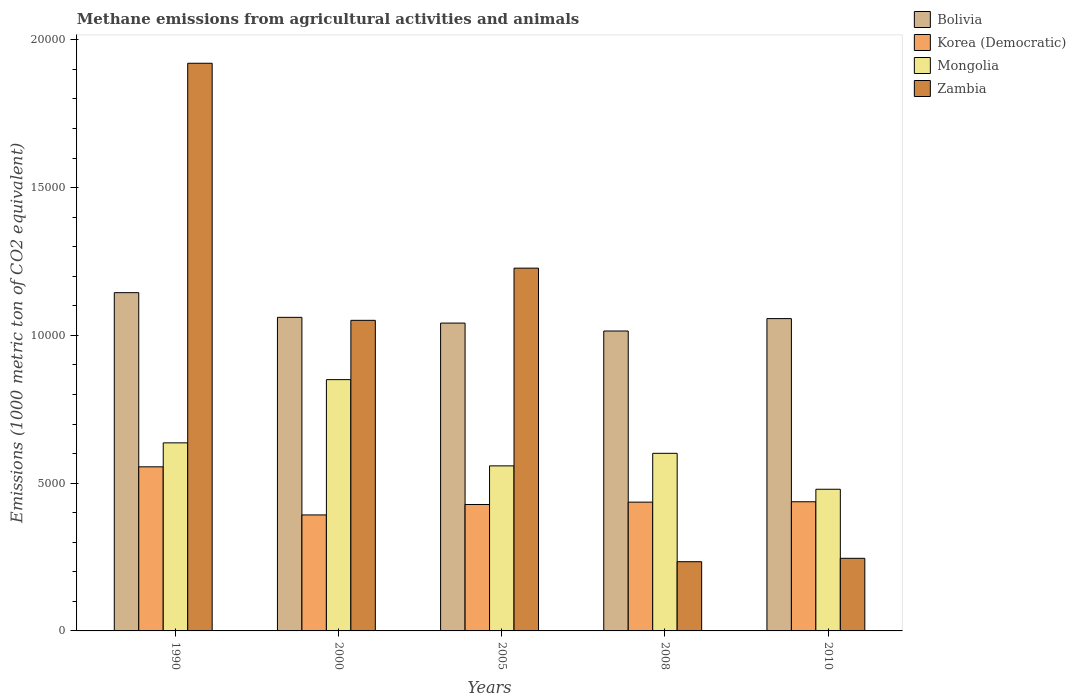Are the number of bars per tick equal to the number of legend labels?
Your answer should be compact. Yes. How many bars are there on the 5th tick from the right?
Make the answer very short. 4. In how many cases, is the number of bars for a given year not equal to the number of legend labels?
Offer a very short reply. 0. What is the amount of methane emitted in Bolivia in 2005?
Give a very brief answer. 1.04e+04. Across all years, what is the maximum amount of methane emitted in Mongolia?
Offer a terse response. 8502.3. Across all years, what is the minimum amount of methane emitted in Zambia?
Provide a short and direct response. 2342.5. What is the total amount of methane emitted in Mongolia in the graph?
Your answer should be very brief. 3.13e+04. What is the difference between the amount of methane emitted in Bolivia in 2000 and that in 2008?
Offer a terse response. 462.2. What is the difference between the amount of methane emitted in Bolivia in 2008 and the amount of methane emitted in Korea (Democratic) in 1990?
Ensure brevity in your answer.  4595.1. What is the average amount of methane emitted in Korea (Democratic) per year?
Give a very brief answer. 4496.54. In the year 2008, what is the difference between the amount of methane emitted in Zambia and amount of methane emitted in Korea (Democratic)?
Provide a succinct answer. -2015.3. What is the ratio of the amount of methane emitted in Korea (Democratic) in 2000 to that in 2010?
Offer a terse response. 0.9. Is the amount of methane emitted in Bolivia in 2005 less than that in 2010?
Give a very brief answer. Yes. What is the difference between the highest and the second highest amount of methane emitted in Mongolia?
Your answer should be very brief. 2138.8. What is the difference between the highest and the lowest amount of methane emitted in Zambia?
Give a very brief answer. 1.69e+04. Is the sum of the amount of methane emitted in Mongolia in 1990 and 2005 greater than the maximum amount of methane emitted in Korea (Democratic) across all years?
Offer a very short reply. Yes. What does the 3rd bar from the left in 2000 represents?
Offer a very short reply. Mongolia. What does the 2nd bar from the right in 2000 represents?
Provide a short and direct response. Mongolia. Is it the case that in every year, the sum of the amount of methane emitted in Korea (Democratic) and amount of methane emitted in Mongolia is greater than the amount of methane emitted in Bolivia?
Provide a succinct answer. No. Are all the bars in the graph horizontal?
Offer a very short reply. No. How many years are there in the graph?
Offer a terse response. 5. What is the difference between two consecutive major ticks on the Y-axis?
Offer a very short reply. 5000. Does the graph contain any zero values?
Your response must be concise. No. Where does the legend appear in the graph?
Your answer should be compact. Top right. How are the legend labels stacked?
Your answer should be very brief. Vertical. What is the title of the graph?
Keep it short and to the point. Methane emissions from agricultural activities and animals. Does "Zimbabwe" appear as one of the legend labels in the graph?
Make the answer very short. No. What is the label or title of the X-axis?
Offer a very short reply. Years. What is the label or title of the Y-axis?
Offer a terse response. Emissions (1000 metric ton of CO2 equivalent). What is the Emissions (1000 metric ton of CO2 equivalent) of Bolivia in 1990?
Your answer should be very brief. 1.14e+04. What is the Emissions (1000 metric ton of CO2 equivalent) in Korea (Democratic) in 1990?
Provide a succinct answer. 5552.4. What is the Emissions (1000 metric ton of CO2 equivalent) in Mongolia in 1990?
Make the answer very short. 6363.5. What is the Emissions (1000 metric ton of CO2 equivalent) in Zambia in 1990?
Offer a very short reply. 1.92e+04. What is the Emissions (1000 metric ton of CO2 equivalent) in Bolivia in 2000?
Keep it short and to the point. 1.06e+04. What is the Emissions (1000 metric ton of CO2 equivalent) in Korea (Democratic) in 2000?
Your response must be concise. 3924.5. What is the Emissions (1000 metric ton of CO2 equivalent) of Mongolia in 2000?
Your response must be concise. 8502.3. What is the Emissions (1000 metric ton of CO2 equivalent) of Zambia in 2000?
Your answer should be very brief. 1.05e+04. What is the Emissions (1000 metric ton of CO2 equivalent) of Bolivia in 2005?
Ensure brevity in your answer.  1.04e+04. What is the Emissions (1000 metric ton of CO2 equivalent) of Korea (Democratic) in 2005?
Your answer should be compact. 4277.9. What is the Emissions (1000 metric ton of CO2 equivalent) of Mongolia in 2005?
Keep it short and to the point. 5584.9. What is the Emissions (1000 metric ton of CO2 equivalent) in Zambia in 2005?
Your answer should be compact. 1.23e+04. What is the Emissions (1000 metric ton of CO2 equivalent) in Bolivia in 2008?
Make the answer very short. 1.01e+04. What is the Emissions (1000 metric ton of CO2 equivalent) in Korea (Democratic) in 2008?
Offer a very short reply. 4357.8. What is the Emissions (1000 metric ton of CO2 equivalent) of Mongolia in 2008?
Offer a very short reply. 6009.3. What is the Emissions (1000 metric ton of CO2 equivalent) of Zambia in 2008?
Offer a very short reply. 2342.5. What is the Emissions (1000 metric ton of CO2 equivalent) of Bolivia in 2010?
Your answer should be very brief. 1.06e+04. What is the Emissions (1000 metric ton of CO2 equivalent) in Korea (Democratic) in 2010?
Ensure brevity in your answer.  4370.1. What is the Emissions (1000 metric ton of CO2 equivalent) in Mongolia in 2010?
Offer a very short reply. 4793.5. What is the Emissions (1000 metric ton of CO2 equivalent) in Zambia in 2010?
Keep it short and to the point. 2457.2. Across all years, what is the maximum Emissions (1000 metric ton of CO2 equivalent) in Bolivia?
Your answer should be very brief. 1.14e+04. Across all years, what is the maximum Emissions (1000 metric ton of CO2 equivalent) in Korea (Democratic)?
Provide a short and direct response. 5552.4. Across all years, what is the maximum Emissions (1000 metric ton of CO2 equivalent) of Mongolia?
Your answer should be compact. 8502.3. Across all years, what is the maximum Emissions (1000 metric ton of CO2 equivalent) of Zambia?
Give a very brief answer. 1.92e+04. Across all years, what is the minimum Emissions (1000 metric ton of CO2 equivalent) of Bolivia?
Give a very brief answer. 1.01e+04. Across all years, what is the minimum Emissions (1000 metric ton of CO2 equivalent) in Korea (Democratic)?
Provide a succinct answer. 3924.5. Across all years, what is the minimum Emissions (1000 metric ton of CO2 equivalent) of Mongolia?
Your response must be concise. 4793.5. Across all years, what is the minimum Emissions (1000 metric ton of CO2 equivalent) of Zambia?
Provide a short and direct response. 2342.5. What is the total Emissions (1000 metric ton of CO2 equivalent) in Bolivia in the graph?
Your response must be concise. 5.32e+04. What is the total Emissions (1000 metric ton of CO2 equivalent) in Korea (Democratic) in the graph?
Keep it short and to the point. 2.25e+04. What is the total Emissions (1000 metric ton of CO2 equivalent) in Mongolia in the graph?
Ensure brevity in your answer.  3.13e+04. What is the total Emissions (1000 metric ton of CO2 equivalent) in Zambia in the graph?
Ensure brevity in your answer.  4.68e+04. What is the difference between the Emissions (1000 metric ton of CO2 equivalent) in Bolivia in 1990 and that in 2000?
Give a very brief answer. 835.3. What is the difference between the Emissions (1000 metric ton of CO2 equivalent) of Korea (Democratic) in 1990 and that in 2000?
Your response must be concise. 1627.9. What is the difference between the Emissions (1000 metric ton of CO2 equivalent) of Mongolia in 1990 and that in 2000?
Your answer should be compact. -2138.8. What is the difference between the Emissions (1000 metric ton of CO2 equivalent) of Zambia in 1990 and that in 2000?
Your response must be concise. 8698.2. What is the difference between the Emissions (1000 metric ton of CO2 equivalent) of Bolivia in 1990 and that in 2005?
Give a very brief answer. 1029.2. What is the difference between the Emissions (1000 metric ton of CO2 equivalent) in Korea (Democratic) in 1990 and that in 2005?
Provide a short and direct response. 1274.5. What is the difference between the Emissions (1000 metric ton of CO2 equivalent) in Mongolia in 1990 and that in 2005?
Your response must be concise. 778.6. What is the difference between the Emissions (1000 metric ton of CO2 equivalent) of Zambia in 1990 and that in 2005?
Your answer should be very brief. 6932.6. What is the difference between the Emissions (1000 metric ton of CO2 equivalent) in Bolivia in 1990 and that in 2008?
Make the answer very short. 1297.5. What is the difference between the Emissions (1000 metric ton of CO2 equivalent) in Korea (Democratic) in 1990 and that in 2008?
Keep it short and to the point. 1194.6. What is the difference between the Emissions (1000 metric ton of CO2 equivalent) of Mongolia in 1990 and that in 2008?
Provide a short and direct response. 354.2. What is the difference between the Emissions (1000 metric ton of CO2 equivalent) in Zambia in 1990 and that in 2008?
Keep it short and to the point. 1.69e+04. What is the difference between the Emissions (1000 metric ton of CO2 equivalent) of Bolivia in 1990 and that in 2010?
Your answer should be compact. 877.3. What is the difference between the Emissions (1000 metric ton of CO2 equivalent) of Korea (Democratic) in 1990 and that in 2010?
Your response must be concise. 1182.3. What is the difference between the Emissions (1000 metric ton of CO2 equivalent) of Mongolia in 1990 and that in 2010?
Keep it short and to the point. 1570. What is the difference between the Emissions (1000 metric ton of CO2 equivalent) in Zambia in 1990 and that in 2010?
Ensure brevity in your answer.  1.67e+04. What is the difference between the Emissions (1000 metric ton of CO2 equivalent) in Bolivia in 2000 and that in 2005?
Make the answer very short. 193.9. What is the difference between the Emissions (1000 metric ton of CO2 equivalent) in Korea (Democratic) in 2000 and that in 2005?
Your answer should be very brief. -353.4. What is the difference between the Emissions (1000 metric ton of CO2 equivalent) in Mongolia in 2000 and that in 2005?
Offer a terse response. 2917.4. What is the difference between the Emissions (1000 metric ton of CO2 equivalent) in Zambia in 2000 and that in 2005?
Your response must be concise. -1765.6. What is the difference between the Emissions (1000 metric ton of CO2 equivalent) of Bolivia in 2000 and that in 2008?
Your response must be concise. 462.2. What is the difference between the Emissions (1000 metric ton of CO2 equivalent) in Korea (Democratic) in 2000 and that in 2008?
Your response must be concise. -433.3. What is the difference between the Emissions (1000 metric ton of CO2 equivalent) in Mongolia in 2000 and that in 2008?
Offer a very short reply. 2493. What is the difference between the Emissions (1000 metric ton of CO2 equivalent) of Zambia in 2000 and that in 2008?
Offer a very short reply. 8166.4. What is the difference between the Emissions (1000 metric ton of CO2 equivalent) of Korea (Democratic) in 2000 and that in 2010?
Your answer should be compact. -445.6. What is the difference between the Emissions (1000 metric ton of CO2 equivalent) in Mongolia in 2000 and that in 2010?
Your answer should be compact. 3708.8. What is the difference between the Emissions (1000 metric ton of CO2 equivalent) in Zambia in 2000 and that in 2010?
Your answer should be compact. 8051.7. What is the difference between the Emissions (1000 metric ton of CO2 equivalent) of Bolivia in 2005 and that in 2008?
Keep it short and to the point. 268.3. What is the difference between the Emissions (1000 metric ton of CO2 equivalent) in Korea (Democratic) in 2005 and that in 2008?
Your response must be concise. -79.9. What is the difference between the Emissions (1000 metric ton of CO2 equivalent) in Mongolia in 2005 and that in 2008?
Ensure brevity in your answer.  -424.4. What is the difference between the Emissions (1000 metric ton of CO2 equivalent) of Zambia in 2005 and that in 2008?
Offer a terse response. 9932. What is the difference between the Emissions (1000 metric ton of CO2 equivalent) in Bolivia in 2005 and that in 2010?
Offer a very short reply. -151.9. What is the difference between the Emissions (1000 metric ton of CO2 equivalent) in Korea (Democratic) in 2005 and that in 2010?
Give a very brief answer. -92.2. What is the difference between the Emissions (1000 metric ton of CO2 equivalent) in Mongolia in 2005 and that in 2010?
Your answer should be compact. 791.4. What is the difference between the Emissions (1000 metric ton of CO2 equivalent) in Zambia in 2005 and that in 2010?
Your answer should be compact. 9817.3. What is the difference between the Emissions (1000 metric ton of CO2 equivalent) of Bolivia in 2008 and that in 2010?
Your response must be concise. -420.2. What is the difference between the Emissions (1000 metric ton of CO2 equivalent) in Mongolia in 2008 and that in 2010?
Make the answer very short. 1215.8. What is the difference between the Emissions (1000 metric ton of CO2 equivalent) in Zambia in 2008 and that in 2010?
Ensure brevity in your answer.  -114.7. What is the difference between the Emissions (1000 metric ton of CO2 equivalent) of Bolivia in 1990 and the Emissions (1000 metric ton of CO2 equivalent) of Korea (Democratic) in 2000?
Keep it short and to the point. 7520.5. What is the difference between the Emissions (1000 metric ton of CO2 equivalent) of Bolivia in 1990 and the Emissions (1000 metric ton of CO2 equivalent) of Mongolia in 2000?
Provide a short and direct response. 2942.7. What is the difference between the Emissions (1000 metric ton of CO2 equivalent) in Bolivia in 1990 and the Emissions (1000 metric ton of CO2 equivalent) in Zambia in 2000?
Provide a short and direct response. 936.1. What is the difference between the Emissions (1000 metric ton of CO2 equivalent) in Korea (Democratic) in 1990 and the Emissions (1000 metric ton of CO2 equivalent) in Mongolia in 2000?
Offer a very short reply. -2949.9. What is the difference between the Emissions (1000 metric ton of CO2 equivalent) of Korea (Democratic) in 1990 and the Emissions (1000 metric ton of CO2 equivalent) of Zambia in 2000?
Your response must be concise. -4956.5. What is the difference between the Emissions (1000 metric ton of CO2 equivalent) in Mongolia in 1990 and the Emissions (1000 metric ton of CO2 equivalent) in Zambia in 2000?
Provide a succinct answer. -4145.4. What is the difference between the Emissions (1000 metric ton of CO2 equivalent) of Bolivia in 1990 and the Emissions (1000 metric ton of CO2 equivalent) of Korea (Democratic) in 2005?
Keep it short and to the point. 7167.1. What is the difference between the Emissions (1000 metric ton of CO2 equivalent) in Bolivia in 1990 and the Emissions (1000 metric ton of CO2 equivalent) in Mongolia in 2005?
Your answer should be very brief. 5860.1. What is the difference between the Emissions (1000 metric ton of CO2 equivalent) in Bolivia in 1990 and the Emissions (1000 metric ton of CO2 equivalent) in Zambia in 2005?
Make the answer very short. -829.5. What is the difference between the Emissions (1000 metric ton of CO2 equivalent) in Korea (Democratic) in 1990 and the Emissions (1000 metric ton of CO2 equivalent) in Mongolia in 2005?
Make the answer very short. -32.5. What is the difference between the Emissions (1000 metric ton of CO2 equivalent) of Korea (Democratic) in 1990 and the Emissions (1000 metric ton of CO2 equivalent) of Zambia in 2005?
Keep it short and to the point. -6722.1. What is the difference between the Emissions (1000 metric ton of CO2 equivalent) in Mongolia in 1990 and the Emissions (1000 metric ton of CO2 equivalent) in Zambia in 2005?
Your response must be concise. -5911. What is the difference between the Emissions (1000 metric ton of CO2 equivalent) of Bolivia in 1990 and the Emissions (1000 metric ton of CO2 equivalent) of Korea (Democratic) in 2008?
Your response must be concise. 7087.2. What is the difference between the Emissions (1000 metric ton of CO2 equivalent) in Bolivia in 1990 and the Emissions (1000 metric ton of CO2 equivalent) in Mongolia in 2008?
Keep it short and to the point. 5435.7. What is the difference between the Emissions (1000 metric ton of CO2 equivalent) in Bolivia in 1990 and the Emissions (1000 metric ton of CO2 equivalent) in Zambia in 2008?
Provide a short and direct response. 9102.5. What is the difference between the Emissions (1000 metric ton of CO2 equivalent) in Korea (Democratic) in 1990 and the Emissions (1000 metric ton of CO2 equivalent) in Mongolia in 2008?
Keep it short and to the point. -456.9. What is the difference between the Emissions (1000 metric ton of CO2 equivalent) of Korea (Democratic) in 1990 and the Emissions (1000 metric ton of CO2 equivalent) of Zambia in 2008?
Give a very brief answer. 3209.9. What is the difference between the Emissions (1000 metric ton of CO2 equivalent) in Mongolia in 1990 and the Emissions (1000 metric ton of CO2 equivalent) in Zambia in 2008?
Give a very brief answer. 4021. What is the difference between the Emissions (1000 metric ton of CO2 equivalent) in Bolivia in 1990 and the Emissions (1000 metric ton of CO2 equivalent) in Korea (Democratic) in 2010?
Provide a short and direct response. 7074.9. What is the difference between the Emissions (1000 metric ton of CO2 equivalent) of Bolivia in 1990 and the Emissions (1000 metric ton of CO2 equivalent) of Mongolia in 2010?
Offer a very short reply. 6651.5. What is the difference between the Emissions (1000 metric ton of CO2 equivalent) in Bolivia in 1990 and the Emissions (1000 metric ton of CO2 equivalent) in Zambia in 2010?
Your response must be concise. 8987.8. What is the difference between the Emissions (1000 metric ton of CO2 equivalent) of Korea (Democratic) in 1990 and the Emissions (1000 metric ton of CO2 equivalent) of Mongolia in 2010?
Your response must be concise. 758.9. What is the difference between the Emissions (1000 metric ton of CO2 equivalent) of Korea (Democratic) in 1990 and the Emissions (1000 metric ton of CO2 equivalent) of Zambia in 2010?
Offer a terse response. 3095.2. What is the difference between the Emissions (1000 metric ton of CO2 equivalent) of Mongolia in 1990 and the Emissions (1000 metric ton of CO2 equivalent) of Zambia in 2010?
Provide a succinct answer. 3906.3. What is the difference between the Emissions (1000 metric ton of CO2 equivalent) of Bolivia in 2000 and the Emissions (1000 metric ton of CO2 equivalent) of Korea (Democratic) in 2005?
Keep it short and to the point. 6331.8. What is the difference between the Emissions (1000 metric ton of CO2 equivalent) of Bolivia in 2000 and the Emissions (1000 metric ton of CO2 equivalent) of Mongolia in 2005?
Your response must be concise. 5024.8. What is the difference between the Emissions (1000 metric ton of CO2 equivalent) of Bolivia in 2000 and the Emissions (1000 metric ton of CO2 equivalent) of Zambia in 2005?
Your response must be concise. -1664.8. What is the difference between the Emissions (1000 metric ton of CO2 equivalent) in Korea (Democratic) in 2000 and the Emissions (1000 metric ton of CO2 equivalent) in Mongolia in 2005?
Keep it short and to the point. -1660.4. What is the difference between the Emissions (1000 metric ton of CO2 equivalent) in Korea (Democratic) in 2000 and the Emissions (1000 metric ton of CO2 equivalent) in Zambia in 2005?
Provide a short and direct response. -8350. What is the difference between the Emissions (1000 metric ton of CO2 equivalent) of Mongolia in 2000 and the Emissions (1000 metric ton of CO2 equivalent) of Zambia in 2005?
Make the answer very short. -3772.2. What is the difference between the Emissions (1000 metric ton of CO2 equivalent) in Bolivia in 2000 and the Emissions (1000 metric ton of CO2 equivalent) in Korea (Democratic) in 2008?
Your answer should be very brief. 6251.9. What is the difference between the Emissions (1000 metric ton of CO2 equivalent) in Bolivia in 2000 and the Emissions (1000 metric ton of CO2 equivalent) in Mongolia in 2008?
Ensure brevity in your answer.  4600.4. What is the difference between the Emissions (1000 metric ton of CO2 equivalent) in Bolivia in 2000 and the Emissions (1000 metric ton of CO2 equivalent) in Zambia in 2008?
Offer a terse response. 8267.2. What is the difference between the Emissions (1000 metric ton of CO2 equivalent) of Korea (Democratic) in 2000 and the Emissions (1000 metric ton of CO2 equivalent) of Mongolia in 2008?
Offer a very short reply. -2084.8. What is the difference between the Emissions (1000 metric ton of CO2 equivalent) of Korea (Democratic) in 2000 and the Emissions (1000 metric ton of CO2 equivalent) of Zambia in 2008?
Your response must be concise. 1582. What is the difference between the Emissions (1000 metric ton of CO2 equivalent) of Mongolia in 2000 and the Emissions (1000 metric ton of CO2 equivalent) of Zambia in 2008?
Your answer should be compact. 6159.8. What is the difference between the Emissions (1000 metric ton of CO2 equivalent) of Bolivia in 2000 and the Emissions (1000 metric ton of CO2 equivalent) of Korea (Democratic) in 2010?
Your answer should be very brief. 6239.6. What is the difference between the Emissions (1000 metric ton of CO2 equivalent) of Bolivia in 2000 and the Emissions (1000 metric ton of CO2 equivalent) of Mongolia in 2010?
Your answer should be compact. 5816.2. What is the difference between the Emissions (1000 metric ton of CO2 equivalent) of Bolivia in 2000 and the Emissions (1000 metric ton of CO2 equivalent) of Zambia in 2010?
Make the answer very short. 8152.5. What is the difference between the Emissions (1000 metric ton of CO2 equivalent) in Korea (Democratic) in 2000 and the Emissions (1000 metric ton of CO2 equivalent) in Mongolia in 2010?
Give a very brief answer. -869. What is the difference between the Emissions (1000 metric ton of CO2 equivalent) in Korea (Democratic) in 2000 and the Emissions (1000 metric ton of CO2 equivalent) in Zambia in 2010?
Provide a short and direct response. 1467.3. What is the difference between the Emissions (1000 metric ton of CO2 equivalent) of Mongolia in 2000 and the Emissions (1000 metric ton of CO2 equivalent) of Zambia in 2010?
Your answer should be very brief. 6045.1. What is the difference between the Emissions (1000 metric ton of CO2 equivalent) in Bolivia in 2005 and the Emissions (1000 metric ton of CO2 equivalent) in Korea (Democratic) in 2008?
Provide a short and direct response. 6058. What is the difference between the Emissions (1000 metric ton of CO2 equivalent) in Bolivia in 2005 and the Emissions (1000 metric ton of CO2 equivalent) in Mongolia in 2008?
Your answer should be compact. 4406.5. What is the difference between the Emissions (1000 metric ton of CO2 equivalent) in Bolivia in 2005 and the Emissions (1000 metric ton of CO2 equivalent) in Zambia in 2008?
Offer a terse response. 8073.3. What is the difference between the Emissions (1000 metric ton of CO2 equivalent) of Korea (Democratic) in 2005 and the Emissions (1000 metric ton of CO2 equivalent) of Mongolia in 2008?
Provide a succinct answer. -1731.4. What is the difference between the Emissions (1000 metric ton of CO2 equivalent) in Korea (Democratic) in 2005 and the Emissions (1000 metric ton of CO2 equivalent) in Zambia in 2008?
Your answer should be compact. 1935.4. What is the difference between the Emissions (1000 metric ton of CO2 equivalent) of Mongolia in 2005 and the Emissions (1000 metric ton of CO2 equivalent) of Zambia in 2008?
Provide a short and direct response. 3242.4. What is the difference between the Emissions (1000 metric ton of CO2 equivalent) in Bolivia in 2005 and the Emissions (1000 metric ton of CO2 equivalent) in Korea (Democratic) in 2010?
Make the answer very short. 6045.7. What is the difference between the Emissions (1000 metric ton of CO2 equivalent) of Bolivia in 2005 and the Emissions (1000 metric ton of CO2 equivalent) of Mongolia in 2010?
Your answer should be compact. 5622.3. What is the difference between the Emissions (1000 metric ton of CO2 equivalent) of Bolivia in 2005 and the Emissions (1000 metric ton of CO2 equivalent) of Zambia in 2010?
Provide a short and direct response. 7958.6. What is the difference between the Emissions (1000 metric ton of CO2 equivalent) in Korea (Democratic) in 2005 and the Emissions (1000 metric ton of CO2 equivalent) in Mongolia in 2010?
Ensure brevity in your answer.  -515.6. What is the difference between the Emissions (1000 metric ton of CO2 equivalent) in Korea (Democratic) in 2005 and the Emissions (1000 metric ton of CO2 equivalent) in Zambia in 2010?
Offer a terse response. 1820.7. What is the difference between the Emissions (1000 metric ton of CO2 equivalent) in Mongolia in 2005 and the Emissions (1000 metric ton of CO2 equivalent) in Zambia in 2010?
Ensure brevity in your answer.  3127.7. What is the difference between the Emissions (1000 metric ton of CO2 equivalent) in Bolivia in 2008 and the Emissions (1000 metric ton of CO2 equivalent) in Korea (Democratic) in 2010?
Give a very brief answer. 5777.4. What is the difference between the Emissions (1000 metric ton of CO2 equivalent) in Bolivia in 2008 and the Emissions (1000 metric ton of CO2 equivalent) in Mongolia in 2010?
Ensure brevity in your answer.  5354. What is the difference between the Emissions (1000 metric ton of CO2 equivalent) of Bolivia in 2008 and the Emissions (1000 metric ton of CO2 equivalent) of Zambia in 2010?
Provide a succinct answer. 7690.3. What is the difference between the Emissions (1000 metric ton of CO2 equivalent) of Korea (Democratic) in 2008 and the Emissions (1000 metric ton of CO2 equivalent) of Mongolia in 2010?
Your answer should be very brief. -435.7. What is the difference between the Emissions (1000 metric ton of CO2 equivalent) in Korea (Democratic) in 2008 and the Emissions (1000 metric ton of CO2 equivalent) in Zambia in 2010?
Your response must be concise. 1900.6. What is the difference between the Emissions (1000 metric ton of CO2 equivalent) in Mongolia in 2008 and the Emissions (1000 metric ton of CO2 equivalent) in Zambia in 2010?
Your answer should be very brief. 3552.1. What is the average Emissions (1000 metric ton of CO2 equivalent) in Bolivia per year?
Make the answer very short. 1.06e+04. What is the average Emissions (1000 metric ton of CO2 equivalent) in Korea (Democratic) per year?
Keep it short and to the point. 4496.54. What is the average Emissions (1000 metric ton of CO2 equivalent) in Mongolia per year?
Ensure brevity in your answer.  6250.7. What is the average Emissions (1000 metric ton of CO2 equivalent) in Zambia per year?
Provide a succinct answer. 9358.04. In the year 1990, what is the difference between the Emissions (1000 metric ton of CO2 equivalent) of Bolivia and Emissions (1000 metric ton of CO2 equivalent) of Korea (Democratic)?
Provide a short and direct response. 5892.6. In the year 1990, what is the difference between the Emissions (1000 metric ton of CO2 equivalent) in Bolivia and Emissions (1000 metric ton of CO2 equivalent) in Mongolia?
Offer a very short reply. 5081.5. In the year 1990, what is the difference between the Emissions (1000 metric ton of CO2 equivalent) in Bolivia and Emissions (1000 metric ton of CO2 equivalent) in Zambia?
Provide a short and direct response. -7762.1. In the year 1990, what is the difference between the Emissions (1000 metric ton of CO2 equivalent) of Korea (Democratic) and Emissions (1000 metric ton of CO2 equivalent) of Mongolia?
Offer a very short reply. -811.1. In the year 1990, what is the difference between the Emissions (1000 metric ton of CO2 equivalent) in Korea (Democratic) and Emissions (1000 metric ton of CO2 equivalent) in Zambia?
Make the answer very short. -1.37e+04. In the year 1990, what is the difference between the Emissions (1000 metric ton of CO2 equivalent) of Mongolia and Emissions (1000 metric ton of CO2 equivalent) of Zambia?
Offer a very short reply. -1.28e+04. In the year 2000, what is the difference between the Emissions (1000 metric ton of CO2 equivalent) of Bolivia and Emissions (1000 metric ton of CO2 equivalent) of Korea (Democratic)?
Make the answer very short. 6685.2. In the year 2000, what is the difference between the Emissions (1000 metric ton of CO2 equivalent) in Bolivia and Emissions (1000 metric ton of CO2 equivalent) in Mongolia?
Give a very brief answer. 2107.4. In the year 2000, what is the difference between the Emissions (1000 metric ton of CO2 equivalent) of Bolivia and Emissions (1000 metric ton of CO2 equivalent) of Zambia?
Offer a very short reply. 100.8. In the year 2000, what is the difference between the Emissions (1000 metric ton of CO2 equivalent) in Korea (Democratic) and Emissions (1000 metric ton of CO2 equivalent) in Mongolia?
Keep it short and to the point. -4577.8. In the year 2000, what is the difference between the Emissions (1000 metric ton of CO2 equivalent) in Korea (Democratic) and Emissions (1000 metric ton of CO2 equivalent) in Zambia?
Keep it short and to the point. -6584.4. In the year 2000, what is the difference between the Emissions (1000 metric ton of CO2 equivalent) in Mongolia and Emissions (1000 metric ton of CO2 equivalent) in Zambia?
Provide a short and direct response. -2006.6. In the year 2005, what is the difference between the Emissions (1000 metric ton of CO2 equivalent) in Bolivia and Emissions (1000 metric ton of CO2 equivalent) in Korea (Democratic)?
Offer a very short reply. 6137.9. In the year 2005, what is the difference between the Emissions (1000 metric ton of CO2 equivalent) of Bolivia and Emissions (1000 metric ton of CO2 equivalent) of Mongolia?
Your answer should be very brief. 4830.9. In the year 2005, what is the difference between the Emissions (1000 metric ton of CO2 equivalent) of Bolivia and Emissions (1000 metric ton of CO2 equivalent) of Zambia?
Ensure brevity in your answer.  -1858.7. In the year 2005, what is the difference between the Emissions (1000 metric ton of CO2 equivalent) in Korea (Democratic) and Emissions (1000 metric ton of CO2 equivalent) in Mongolia?
Offer a very short reply. -1307. In the year 2005, what is the difference between the Emissions (1000 metric ton of CO2 equivalent) of Korea (Democratic) and Emissions (1000 metric ton of CO2 equivalent) of Zambia?
Your answer should be very brief. -7996.6. In the year 2005, what is the difference between the Emissions (1000 metric ton of CO2 equivalent) of Mongolia and Emissions (1000 metric ton of CO2 equivalent) of Zambia?
Your answer should be compact. -6689.6. In the year 2008, what is the difference between the Emissions (1000 metric ton of CO2 equivalent) in Bolivia and Emissions (1000 metric ton of CO2 equivalent) in Korea (Democratic)?
Offer a terse response. 5789.7. In the year 2008, what is the difference between the Emissions (1000 metric ton of CO2 equivalent) in Bolivia and Emissions (1000 metric ton of CO2 equivalent) in Mongolia?
Provide a succinct answer. 4138.2. In the year 2008, what is the difference between the Emissions (1000 metric ton of CO2 equivalent) in Bolivia and Emissions (1000 metric ton of CO2 equivalent) in Zambia?
Make the answer very short. 7805. In the year 2008, what is the difference between the Emissions (1000 metric ton of CO2 equivalent) of Korea (Democratic) and Emissions (1000 metric ton of CO2 equivalent) of Mongolia?
Provide a short and direct response. -1651.5. In the year 2008, what is the difference between the Emissions (1000 metric ton of CO2 equivalent) in Korea (Democratic) and Emissions (1000 metric ton of CO2 equivalent) in Zambia?
Provide a succinct answer. 2015.3. In the year 2008, what is the difference between the Emissions (1000 metric ton of CO2 equivalent) of Mongolia and Emissions (1000 metric ton of CO2 equivalent) of Zambia?
Your answer should be very brief. 3666.8. In the year 2010, what is the difference between the Emissions (1000 metric ton of CO2 equivalent) in Bolivia and Emissions (1000 metric ton of CO2 equivalent) in Korea (Democratic)?
Offer a very short reply. 6197.6. In the year 2010, what is the difference between the Emissions (1000 metric ton of CO2 equivalent) of Bolivia and Emissions (1000 metric ton of CO2 equivalent) of Mongolia?
Provide a succinct answer. 5774.2. In the year 2010, what is the difference between the Emissions (1000 metric ton of CO2 equivalent) in Bolivia and Emissions (1000 metric ton of CO2 equivalent) in Zambia?
Offer a very short reply. 8110.5. In the year 2010, what is the difference between the Emissions (1000 metric ton of CO2 equivalent) in Korea (Democratic) and Emissions (1000 metric ton of CO2 equivalent) in Mongolia?
Provide a short and direct response. -423.4. In the year 2010, what is the difference between the Emissions (1000 metric ton of CO2 equivalent) of Korea (Democratic) and Emissions (1000 metric ton of CO2 equivalent) of Zambia?
Offer a terse response. 1912.9. In the year 2010, what is the difference between the Emissions (1000 metric ton of CO2 equivalent) of Mongolia and Emissions (1000 metric ton of CO2 equivalent) of Zambia?
Your response must be concise. 2336.3. What is the ratio of the Emissions (1000 metric ton of CO2 equivalent) in Bolivia in 1990 to that in 2000?
Offer a very short reply. 1.08. What is the ratio of the Emissions (1000 metric ton of CO2 equivalent) in Korea (Democratic) in 1990 to that in 2000?
Give a very brief answer. 1.41. What is the ratio of the Emissions (1000 metric ton of CO2 equivalent) of Mongolia in 1990 to that in 2000?
Give a very brief answer. 0.75. What is the ratio of the Emissions (1000 metric ton of CO2 equivalent) in Zambia in 1990 to that in 2000?
Make the answer very short. 1.83. What is the ratio of the Emissions (1000 metric ton of CO2 equivalent) of Bolivia in 1990 to that in 2005?
Give a very brief answer. 1.1. What is the ratio of the Emissions (1000 metric ton of CO2 equivalent) of Korea (Democratic) in 1990 to that in 2005?
Your response must be concise. 1.3. What is the ratio of the Emissions (1000 metric ton of CO2 equivalent) of Mongolia in 1990 to that in 2005?
Your answer should be compact. 1.14. What is the ratio of the Emissions (1000 metric ton of CO2 equivalent) in Zambia in 1990 to that in 2005?
Keep it short and to the point. 1.56. What is the ratio of the Emissions (1000 metric ton of CO2 equivalent) of Bolivia in 1990 to that in 2008?
Provide a short and direct response. 1.13. What is the ratio of the Emissions (1000 metric ton of CO2 equivalent) of Korea (Democratic) in 1990 to that in 2008?
Give a very brief answer. 1.27. What is the ratio of the Emissions (1000 metric ton of CO2 equivalent) in Mongolia in 1990 to that in 2008?
Your answer should be very brief. 1.06. What is the ratio of the Emissions (1000 metric ton of CO2 equivalent) in Zambia in 1990 to that in 2008?
Your response must be concise. 8.2. What is the ratio of the Emissions (1000 metric ton of CO2 equivalent) of Bolivia in 1990 to that in 2010?
Make the answer very short. 1.08. What is the ratio of the Emissions (1000 metric ton of CO2 equivalent) of Korea (Democratic) in 1990 to that in 2010?
Your answer should be compact. 1.27. What is the ratio of the Emissions (1000 metric ton of CO2 equivalent) of Mongolia in 1990 to that in 2010?
Make the answer very short. 1.33. What is the ratio of the Emissions (1000 metric ton of CO2 equivalent) in Zambia in 1990 to that in 2010?
Offer a very short reply. 7.82. What is the ratio of the Emissions (1000 metric ton of CO2 equivalent) in Bolivia in 2000 to that in 2005?
Your answer should be compact. 1.02. What is the ratio of the Emissions (1000 metric ton of CO2 equivalent) of Korea (Democratic) in 2000 to that in 2005?
Offer a terse response. 0.92. What is the ratio of the Emissions (1000 metric ton of CO2 equivalent) in Mongolia in 2000 to that in 2005?
Give a very brief answer. 1.52. What is the ratio of the Emissions (1000 metric ton of CO2 equivalent) in Zambia in 2000 to that in 2005?
Make the answer very short. 0.86. What is the ratio of the Emissions (1000 metric ton of CO2 equivalent) in Bolivia in 2000 to that in 2008?
Your answer should be compact. 1.05. What is the ratio of the Emissions (1000 metric ton of CO2 equivalent) in Korea (Democratic) in 2000 to that in 2008?
Offer a terse response. 0.9. What is the ratio of the Emissions (1000 metric ton of CO2 equivalent) of Mongolia in 2000 to that in 2008?
Offer a terse response. 1.41. What is the ratio of the Emissions (1000 metric ton of CO2 equivalent) in Zambia in 2000 to that in 2008?
Make the answer very short. 4.49. What is the ratio of the Emissions (1000 metric ton of CO2 equivalent) of Korea (Democratic) in 2000 to that in 2010?
Your answer should be very brief. 0.9. What is the ratio of the Emissions (1000 metric ton of CO2 equivalent) of Mongolia in 2000 to that in 2010?
Offer a very short reply. 1.77. What is the ratio of the Emissions (1000 metric ton of CO2 equivalent) of Zambia in 2000 to that in 2010?
Provide a succinct answer. 4.28. What is the ratio of the Emissions (1000 metric ton of CO2 equivalent) in Bolivia in 2005 to that in 2008?
Offer a terse response. 1.03. What is the ratio of the Emissions (1000 metric ton of CO2 equivalent) in Korea (Democratic) in 2005 to that in 2008?
Provide a short and direct response. 0.98. What is the ratio of the Emissions (1000 metric ton of CO2 equivalent) of Mongolia in 2005 to that in 2008?
Your response must be concise. 0.93. What is the ratio of the Emissions (1000 metric ton of CO2 equivalent) of Zambia in 2005 to that in 2008?
Ensure brevity in your answer.  5.24. What is the ratio of the Emissions (1000 metric ton of CO2 equivalent) of Bolivia in 2005 to that in 2010?
Provide a short and direct response. 0.99. What is the ratio of the Emissions (1000 metric ton of CO2 equivalent) of Korea (Democratic) in 2005 to that in 2010?
Provide a short and direct response. 0.98. What is the ratio of the Emissions (1000 metric ton of CO2 equivalent) of Mongolia in 2005 to that in 2010?
Your answer should be very brief. 1.17. What is the ratio of the Emissions (1000 metric ton of CO2 equivalent) in Zambia in 2005 to that in 2010?
Provide a short and direct response. 5. What is the ratio of the Emissions (1000 metric ton of CO2 equivalent) of Bolivia in 2008 to that in 2010?
Offer a very short reply. 0.96. What is the ratio of the Emissions (1000 metric ton of CO2 equivalent) of Mongolia in 2008 to that in 2010?
Provide a short and direct response. 1.25. What is the ratio of the Emissions (1000 metric ton of CO2 equivalent) of Zambia in 2008 to that in 2010?
Provide a short and direct response. 0.95. What is the difference between the highest and the second highest Emissions (1000 metric ton of CO2 equivalent) of Bolivia?
Your answer should be compact. 835.3. What is the difference between the highest and the second highest Emissions (1000 metric ton of CO2 equivalent) in Korea (Democratic)?
Make the answer very short. 1182.3. What is the difference between the highest and the second highest Emissions (1000 metric ton of CO2 equivalent) in Mongolia?
Offer a very short reply. 2138.8. What is the difference between the highest and the second highest Emissions (1000 metric ton of CO2 equivalent) of Zambia?
Offer a very short reply. 6932.6. What is the difference between the highest and the lowest Emissions (1000 metric ton of CO2 equivalent) of Bolivia?
Provide a succinct answer. 1297.5. What is the difference between the highest and the lowest Emissions (1000 metric ton of CO2 equivalent) of Korea (Democratic)?
Make the answer very short. 1627.9. What is the difference between the highest and the lowest Emissions (1000 metric ton of CO2 equivalent) in Mongolia?
Provide a succinct answer. 3708.8. What is the difference between the highest and the lowest Emissions (1000 metric ton of CO2 equivalent) in Zambia?
Provide a short and direct response. 1.69e+04. 